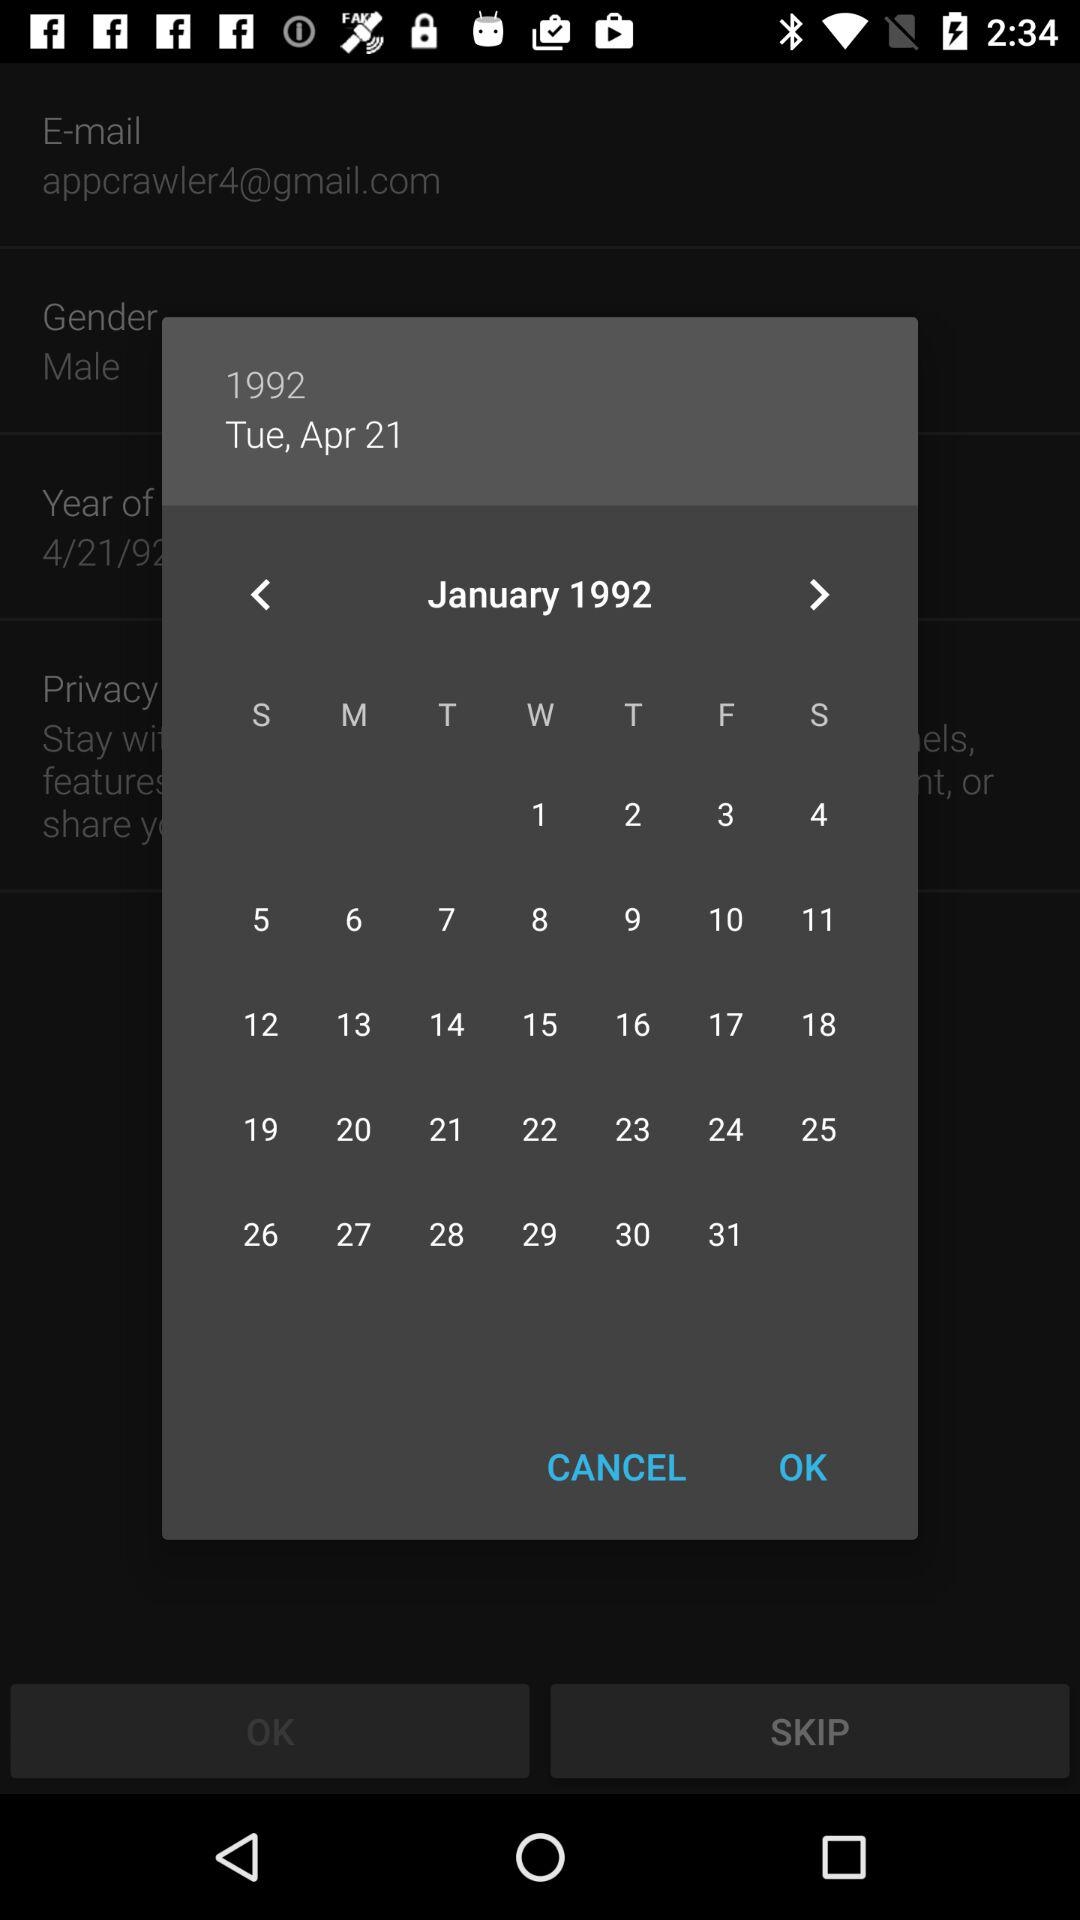What date is shown? The shown date is Tuesday, April 21, 1992. 